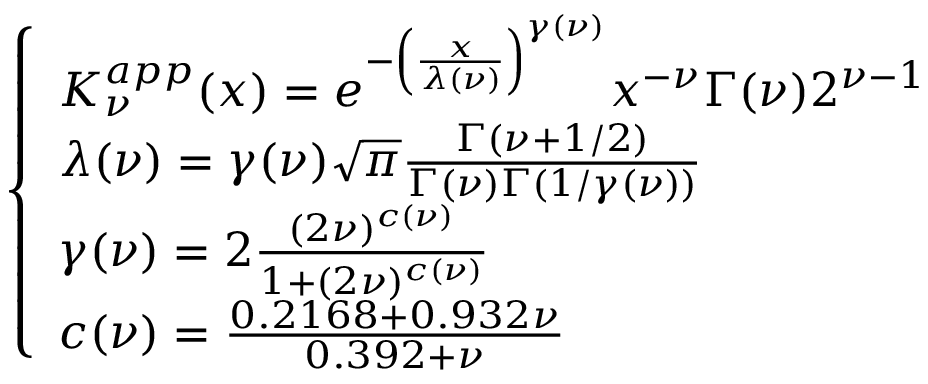Convert formula to latex. <formula><loc_0><loc_0><loc_500><loc_500>\begin{array} { r } { \left \{ \begin{array} { l l } { K _ { \nu } ^ { a p p } ( x ) = e ^ { - \left ( \frac { x } { \lambda ( \nu ) } \right ) ^ { \gamma ( \nu ) } } x ^ { - \nu } \Gamma ( \nu ) 2 ^ { \nu - 1 } } \\ { \lambda ( \nu ) = \gamma ( \nu ) \sqrt { \pi } \frac { \Gamma ( \nu + 1 / 2 ) } { \Gamma ( \nu ) \Gamma ( 1 / \gamma ( \nu ) ) } } \\ { \gamma ( \nu ) = 2 \frac { ( 2 \nu ) ^ { c ( \nu ) } } { 1 + ( 2 \nu ) ^ { c ( \nu ) } } } \\ { c ( \nu ) = \frac { 0 . 2 1 6 8 + 0 . 9 3 2 \nu } { 0 . 3 9 2 + \nu } } \end{array} } \end{array}</formula> 